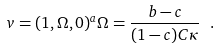Convert formula to latex. <formula><loc_0><loc_0><loc_500><loc_500>v = ( 1 , \Omega , 0 ) ^ { a } \Omega = \frac { b - c } { ( 1 - c ) C \kappa } \ .</formula> 